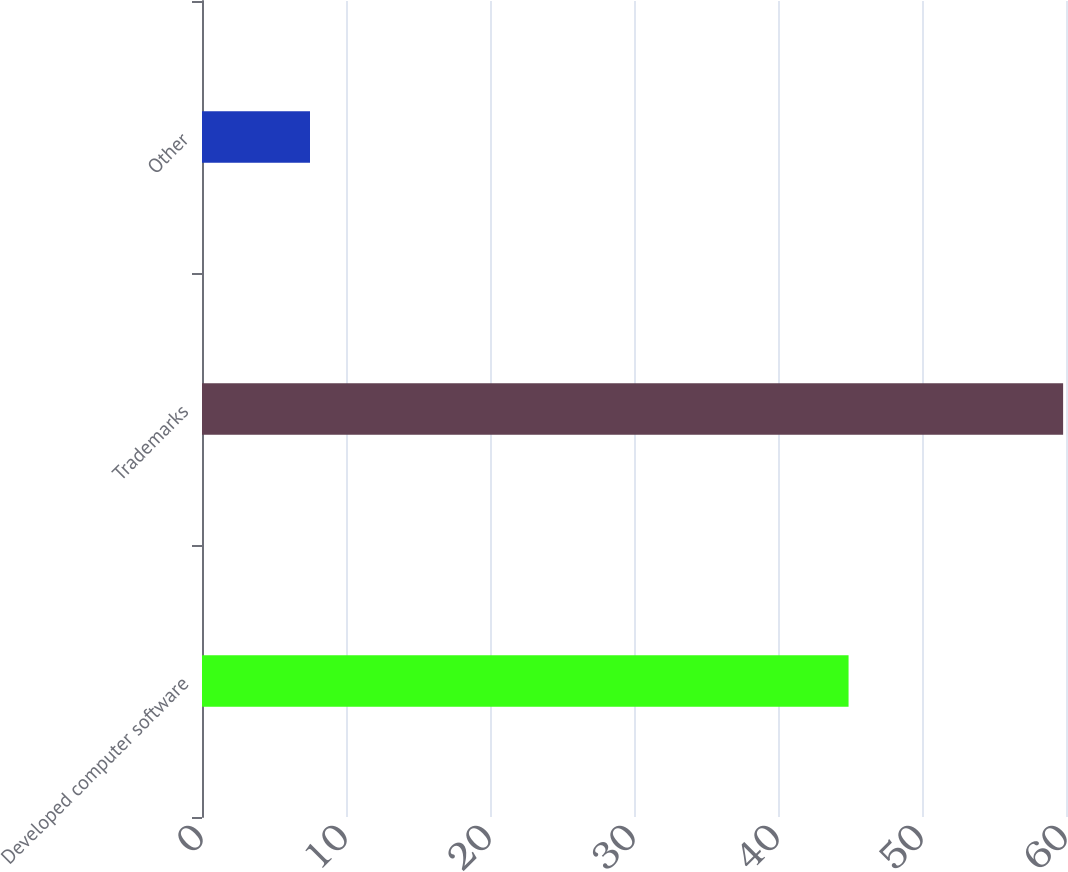Convert chart. <chart><loc_0><loc_0><loc_500><loc_500><bar_chart><fcel>Developed computer software<fcel>Trademarks<fcel>Other<nl><fcel>44.9<fcel>59.8<fcel>7.5<nl></chart> 